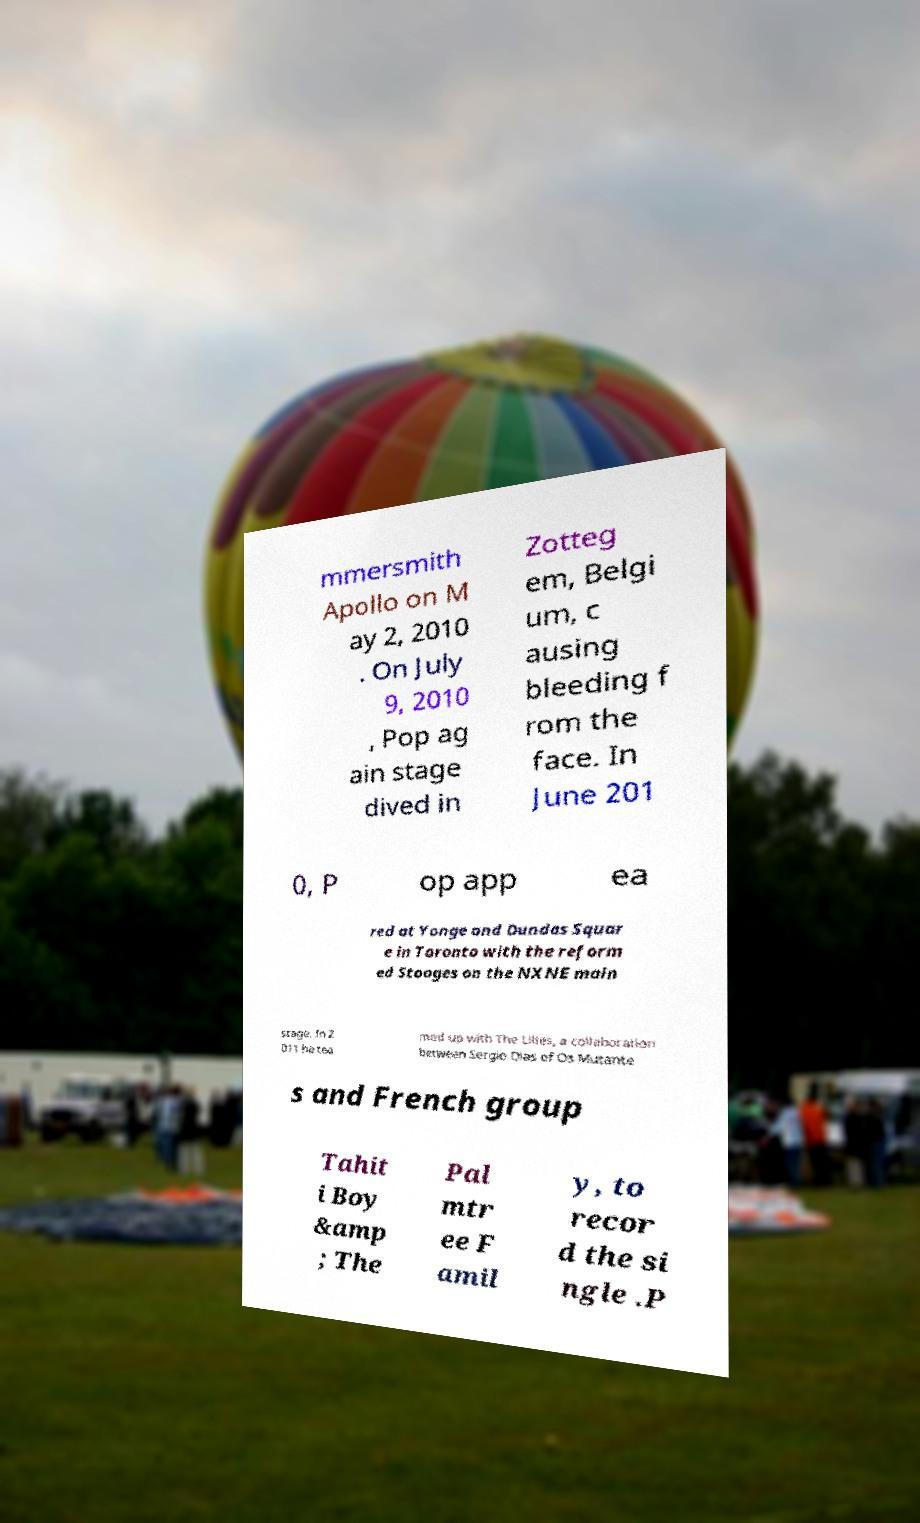For documentation purposes, I need the text within this image transcribed. Could you provide that? mmersmith Apollo on M ay 2, 2010 . On July 9, 2010 , Pop ag ain stage dived in Zotteg em, Belgi um, c ausing bleeding f rom the face. In June 201 0, P op app ea red at Yonge and Dundas Squar e in Toronto with the reform ed Stooges on the NXNE main stage. In 2 011 he tea med up with The Lilies, a collaboration between Sergio Dias of Os Mutante s and French group Tahit i Boy &amp ; The Pal mtr ee F amil y, to recor d the si ngle .P 